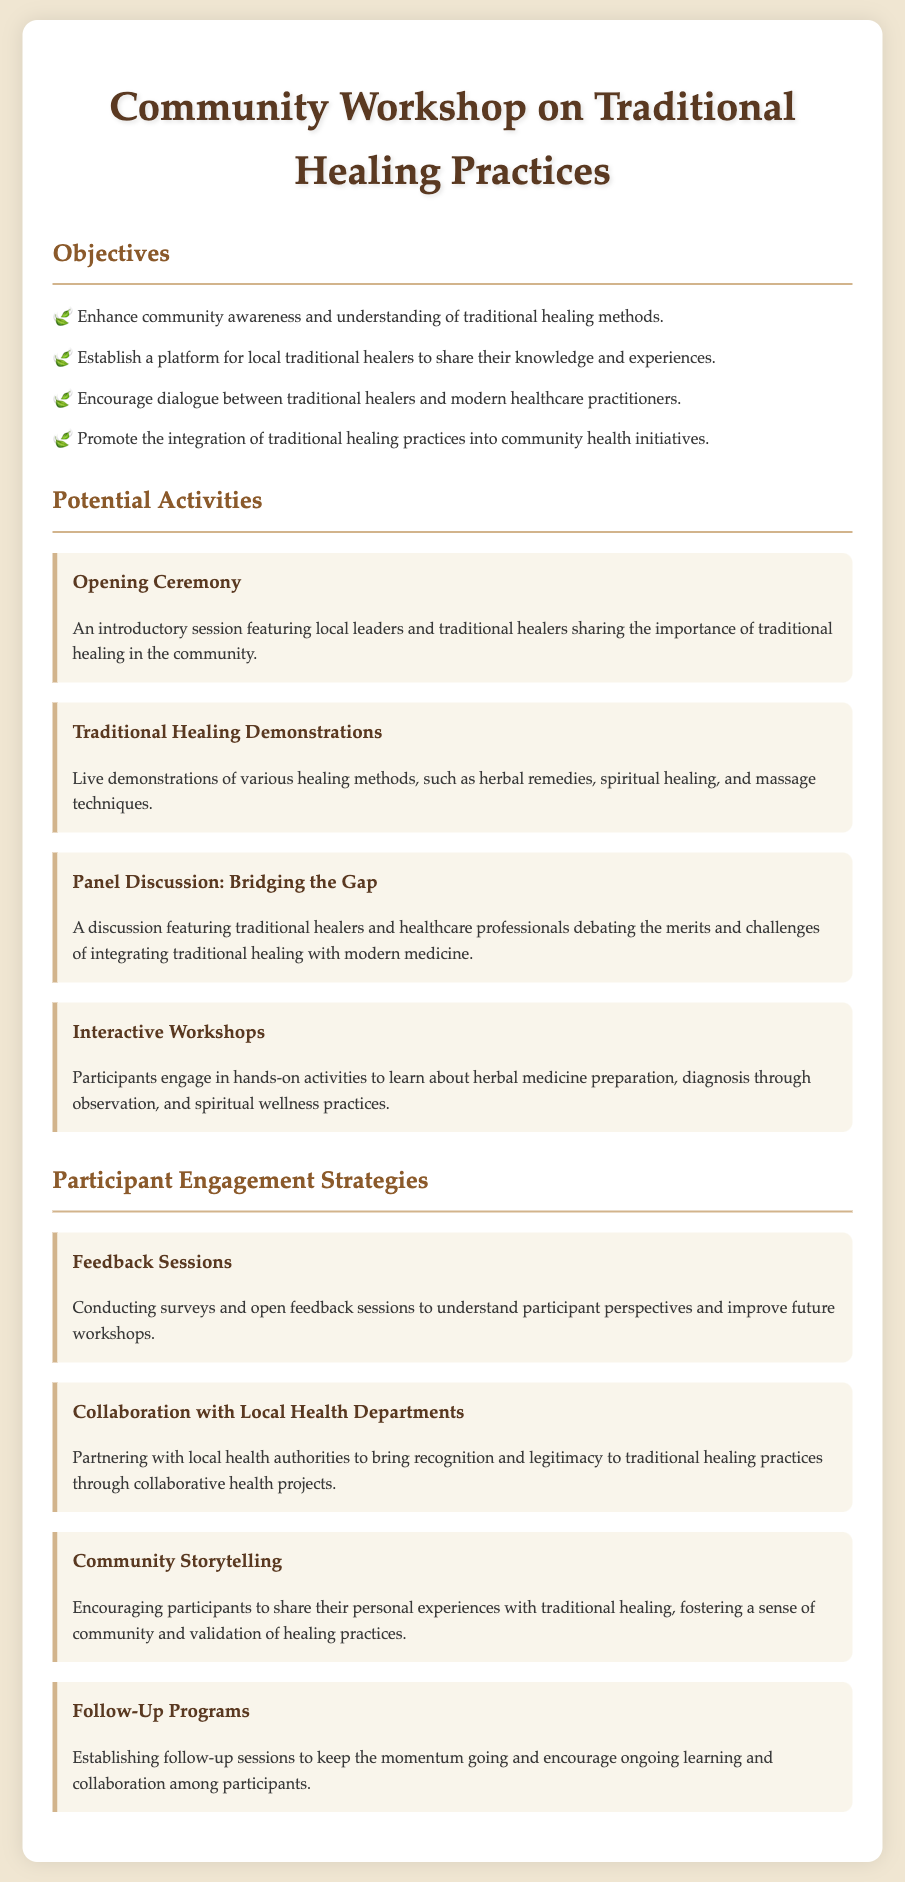what is the title of the document? The title is provided at the top of the document.
Answer: Community Workshop on Traditional Healing Practices how many objectives are listed in the document? The number of objectives is specified in the corresponding section.
Answer: four what is one of the potential activities mentioned? An example of an activity can be found in the potential activities section.
Answer: Traditional Healing Demonstrations who will participate in the panel discussion? The participants in the panel discussion are described in the document.
Answer: traditional healers and healthcare professionals what is a strategy to engage participants? The strategies for participant engagement are outlined in their section.
Answer: Feedback Sessions which activity involves hands-on learning? The document specifies which activity allows participants to engage in hands-on learning.
Answer: Interactive Workshops what type of sessions will help improve future workshops? The document indicates a specific method for gathering insights.
Answer: Feedback Sessions name one aspect that the workshop aims to promote. The document details aspects of traditional healing methods that the workshop aims to enhance.
Answer: integration of traditional healing practices 